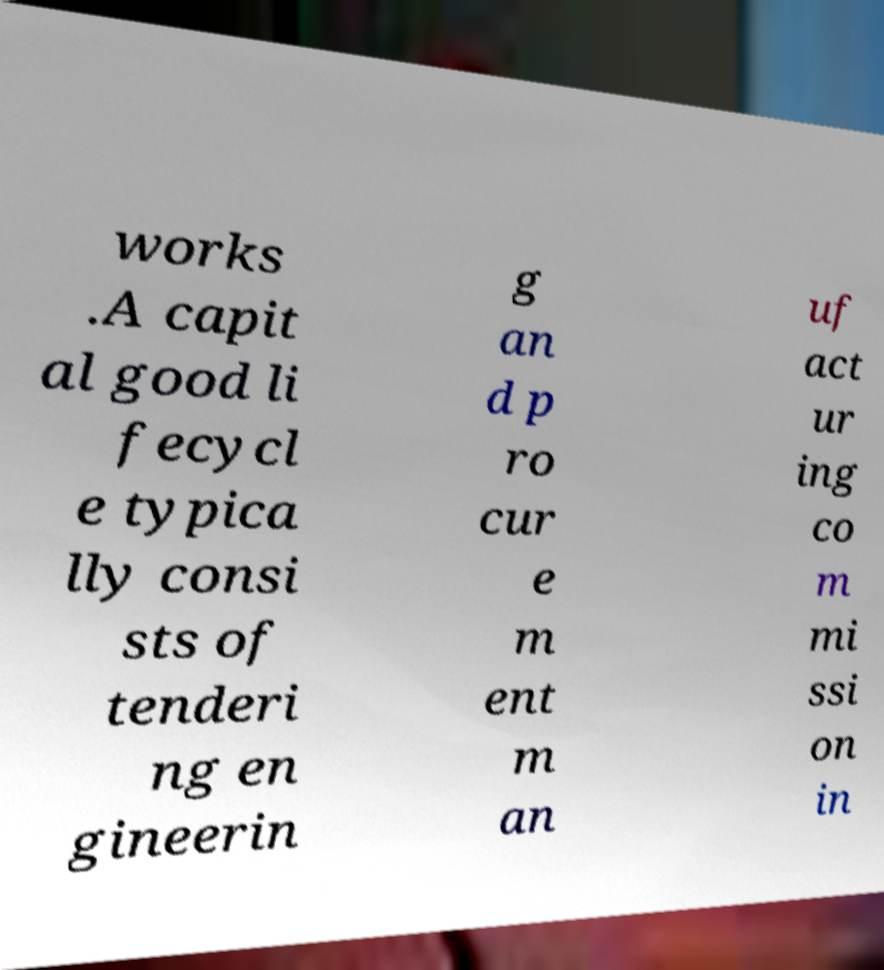There's text embedded in this image that I need extracted. Can you transcribe it verbatim? works .A capit al good li fecycl e typica lly consi sts of tenderi ng en gineerin g an d p ro cur e m ent m an uf act ur ing co m mi ssi on in 